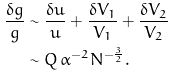<formula> <loc_0><loc_0><loc_500><loc_500>\frac { \delta g } { g } & \sim \frac { \delta u } { u } + \frac { \delta V _ { 1 } } { V _ { 1 } } + \frac { \delta V _ { 2 } } { V _ { 2 } } \\ & \sim Q \, \alpha ^ { - 2 } N ^ { - \frac { 3 } { 2 } } .</formula> 